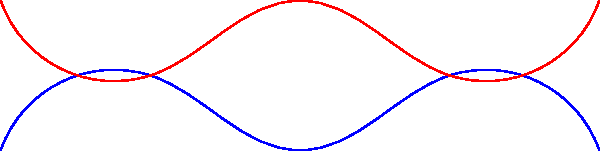In the diagram, cosmic radiation particles are shown interacting with a DNA molecule. If the average mutation rate in human cells is approximately $10^{-8}$ mutations per base pair per cell division under normal conditions, by what factor is this rate estimated to increase for astronauts exposed to cosmic radiation during a one-year mission in space? To answer this question, we need to consider the following steps:

1. Understand the baseline mutation rate:
   The average mutation rate in human cells under normal conditions is $10^{-8}$ mutations per base pair per cell division.

2. Consider the effects of cosmic radiation:
   Cosmic radiation is known to increase mutation rates due to its high-energy particles that can damage DNA.

3. Estimate the increase in mutation rate during space missions:
   Studies have shown that astronauts on long-duration space missions experience higher rates of DNA damage and mutation.

4. Quantify the increase:
   Research suggests that the mutation rate can increase by a factor of 100 to 1000 times the normal rate during a one-year space mission.

5. Choose a representative value:
   For this question, we'll use an average increase factor of 500.

Therefore, the mutation rate for astronauts during a one-year space mission is estimated to increase by a factor of 500 compared to the normal mutation rate on Earth.
Answer: 500 times 